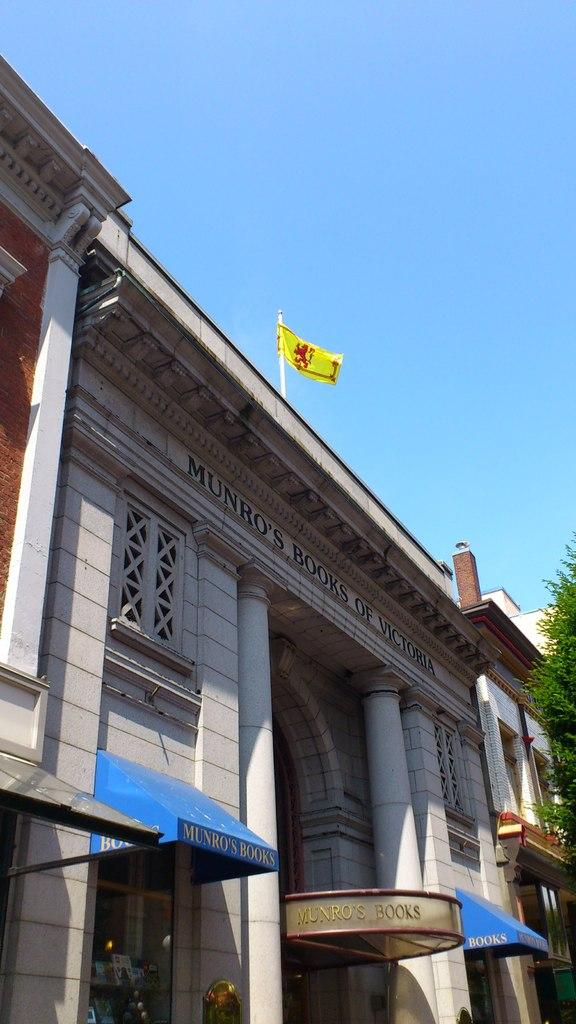What type of structure is visible in the image? There is a building in the image. What other natural or man-made elements can be seen in the image? There is a tree in the image. What is located at the top of the building? There is a flag at the top of the building. How many rabbits are sitting on the icicle in the image? There are no rabbits or icicles present in the image. What type of chicken can be seen in the image? There are no chickens present in the image. 